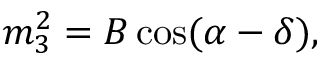<formula> <loc_0><loc_0><loc_500><loc_500>m _ { 3 } ^ { 2 } = B \cos ( \alpha - \delta ) ,</formula> 